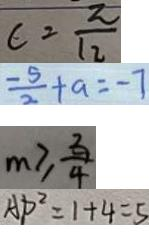Convert formula to latex. <formula><loc_0><loc_0><loc_500><loc_500>c = \frac { 2 } { 1 2 } 
 \frac { - 5 } { 2 } + a = - 7 
 m \geq \frac { 3 } { 4 } 
 A D ^ { 2 } = 1 + 4 = 5</formula> 